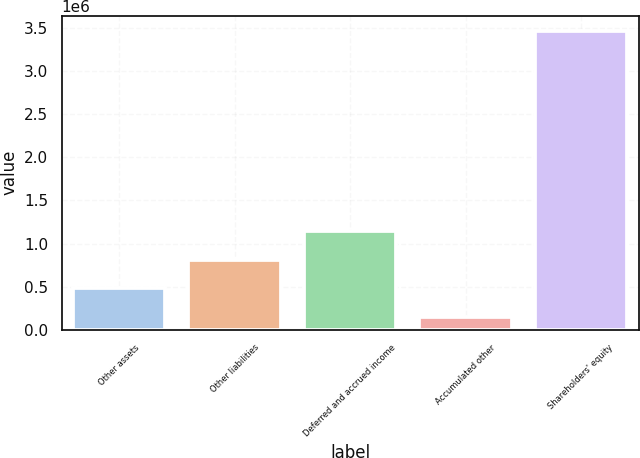Convert chart to OTSL. <chart><loc_0><loc_0><loc_500><loc_500><bar_chart><fcel>Other assets<fcel>Other liabilities<fcel>Deferred and accrued income<fcel>Accumulated other<fcel>Shareholders' equity<nl><fcel>480922<fcel>812831<fcel>1.14474e+06<fcel>149012<fcel>3.46811e+06<nl></chart> 